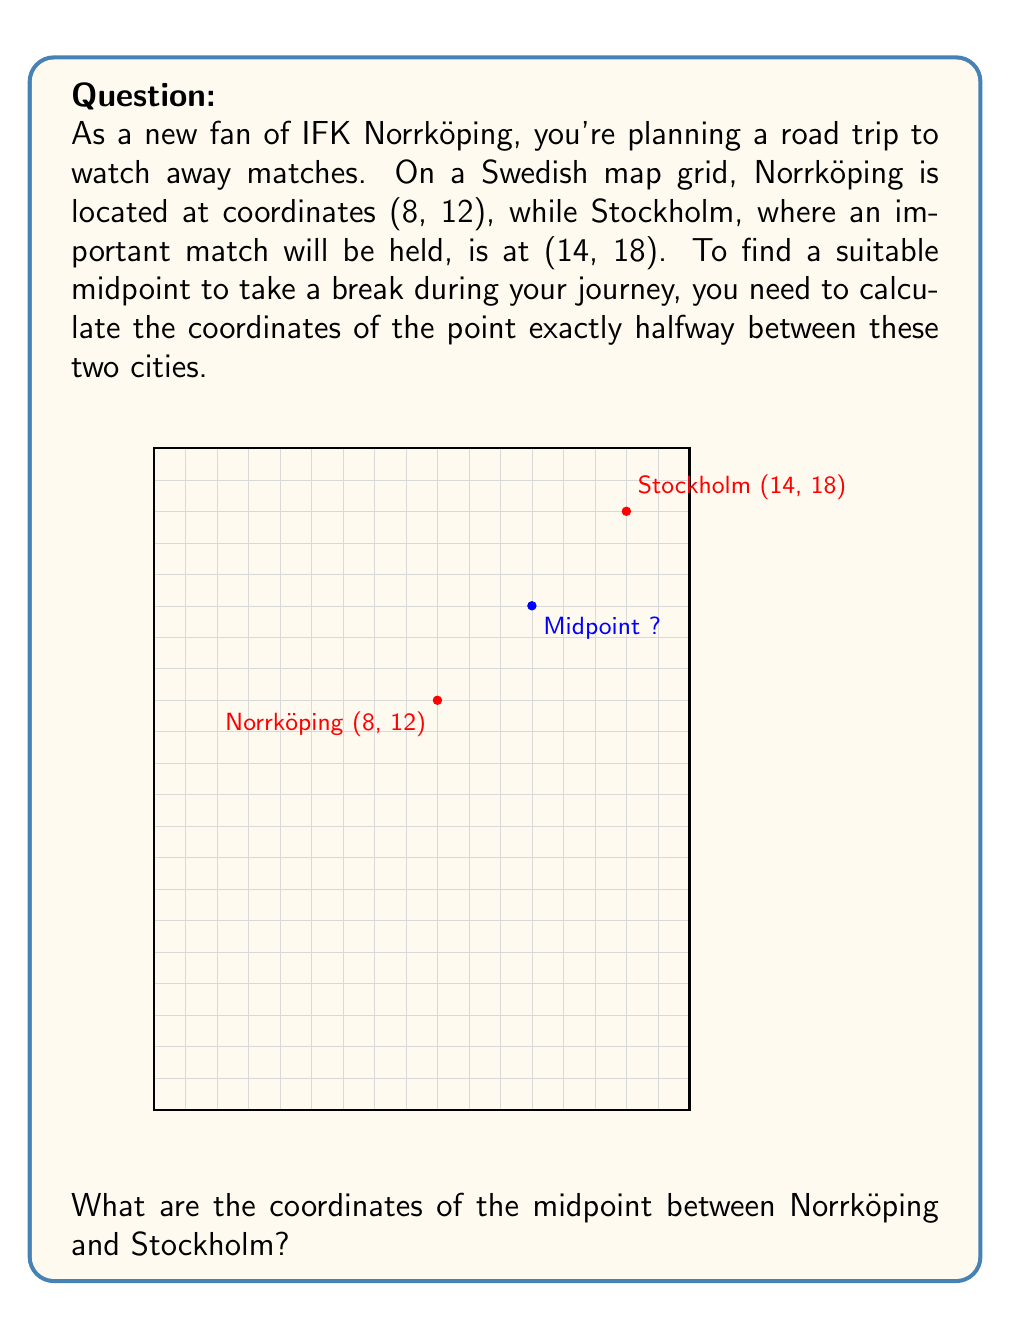Provide a solution to this math problem. To find the midpoint between two points on a coordinate plane, we use the midpoint formula:

$$ \text{Midpoint} = \left(\frac{x_1 + x_2}{2}, \frac{y_1 + y_2}{2}\right) $$

Where $(x_1, y_1)$ are the coordinates of the first point and $(x_2, y_2)$ are the coordinates of the second point.

Given:
- Norrköping: $(x_1, y_1) = (8, 12)$
- Stockholm: $(x_2, y_2) = (14, 18)$

Step 1: Calculate the x-coordinate of the midpoint:
$$ x_{\text{midpoint}} = \frac{x_1 + x_2}{2} = \frac{8 + 14}{2} = \frac{22}{2} = 11 $$

Step 2: Calculate the y-coordinate of the midpoint:
$$ y_{\text{midpoint}} = \frac{y_1 + y_2}{2} = \frac{12 + 18}{2} = \frac{30}{2} = 15 $$

Therefore, the midpoint coordinates are (11, 15).
Answer: (11, 15) 